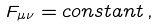<formula> <loc_0><loc_0><loc_500><loc_500>F _ { \mu \nu } = c o n s t a n t \, ,</formula> 